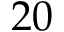<formula> <loc_0><loc_0><loc_500><loc_500>2 0</formula> 